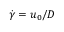<formula> <loc_0><loc_0><loc_500><loc_500>\dot { \gamma } = { { u } _ { 0 } } / D</formula> 